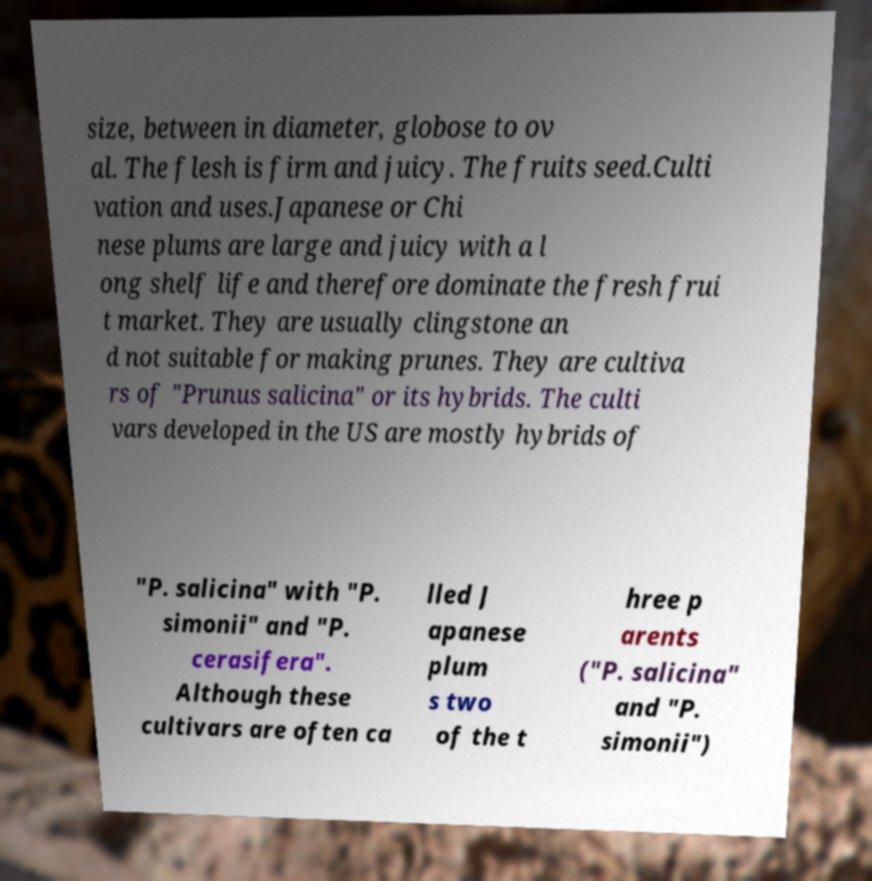For documentation purposes, I need the text within this image transcribed. Could you provide that? size, between in diameter, globose to ov al. The flesh is firm and juicy. The fruits seed.Culti vation and uses.Japanese or Chi nese plums are large and juicy with a l ong shelf life and therefore dominate the fresh frui t market. They are usually clingstone an d not suitable for making prunes. They are cultiva rs of "Prunus salicina" or its hybrids. The culti vars developed in the US are mostly hybrids of "P. salicina" with "P. simonii" and "P. cerasifera". Although these cultivars are often ca lled J apanese plum s two of the t hree p arents ("P. salicina" and "P. simonii") 